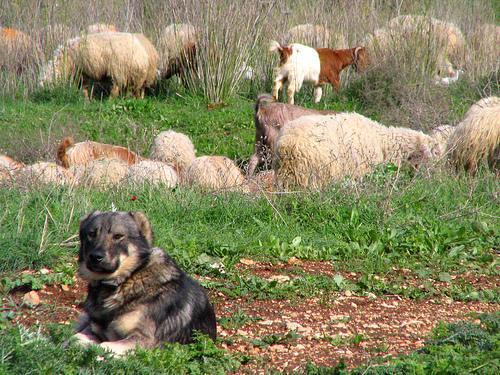How many sheep are visible?
Give a very brief answer. 6. 